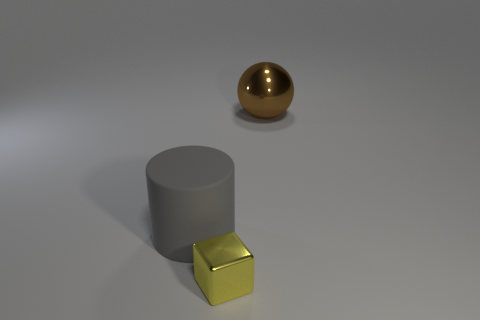There is a shiny thing behind the metal object that is in front of the large cylinder; how big is it?
Offer a very short reply. Large. What number of things are either brown spheres that are to the right of the big gray cylinder or things that are left of the large ball?
Give a very brief answer. 3. Are there fewer tiny blue shiny cylinders than large brown things?
Your response must be concise. Yes. How many things are blue metallic objects or brown objects?
Provide a succinct answer. 1. Is there any other thing that has the same material as the big gray cylinder?
Make the answer very short. No. Do the object behind the gray cylinder and the object that is on the left side of the tiny shiny thing have the same size?
Your answer should be compact. Yes. What material is the object that is both behind the small object and right of the large gray matte thing?
Give a very brief answer. Metal. Are there fewer large rubber cylinders that are behind the small metallic cube than big things?
Provide a short and direct response. Yes. Are there more tiny yellow cubes than small cyan metal cylinders?
Your answer should be compact. Yes. There is a metallic thing that is to the left of the metal thing behind the yellow metallic block; are there any objects behind it?
Ensure brevity in your answer.  Yes. 